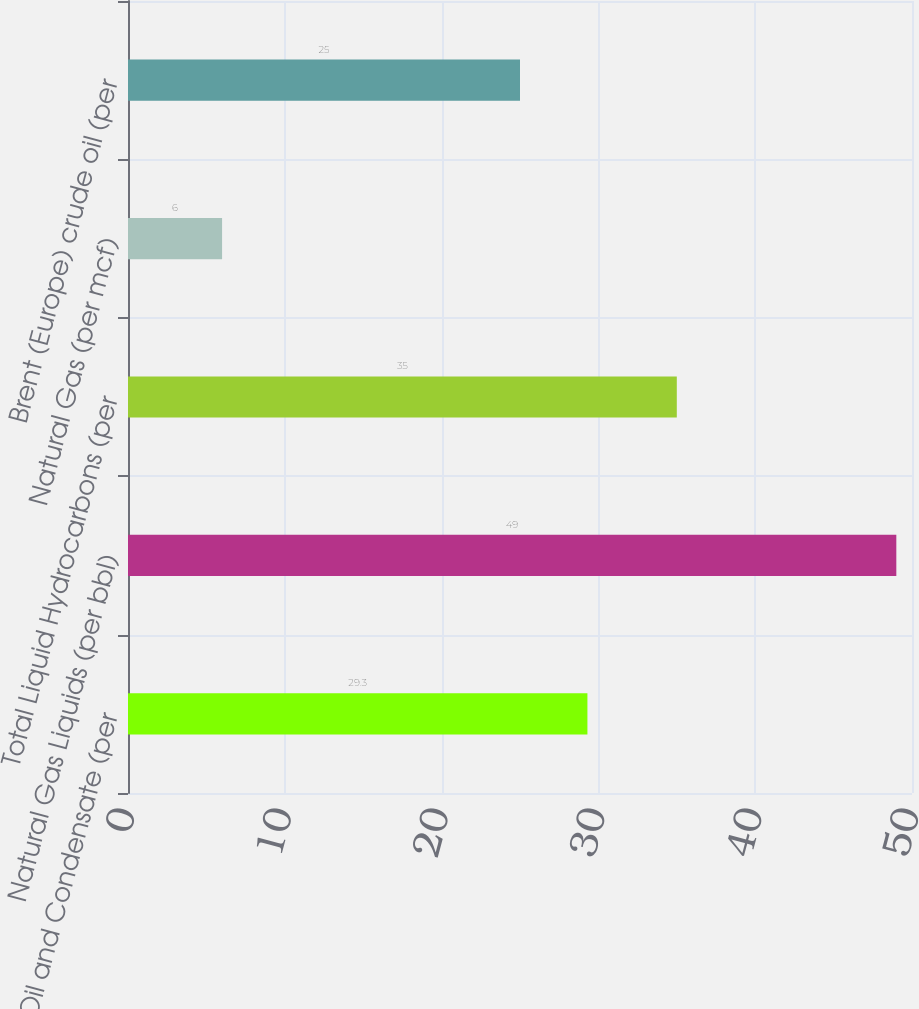<chart> <loc_0><loc_0><loc_500><loc_500><bar_chart><fcel>Crude Oil and Condensate (per<fcel>Natural Gas Liquids (per bbl)<fcel>Total Liquid Hydrocarbons (per<fcel>Natural Gas (per mcf)<fcel>Brent (Europe) crude oil (per<nl><fcel>29.3<fcel>49<fcel>35<fcel>6<fcel>25<nl></chart> 